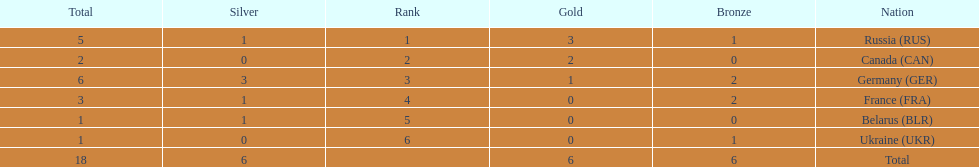Give me the full table as a dictionary. {'header': ['Total', 'Silver', 'Rank', 'Gold', 'Bronze', 'Nation'], 'rows': [['5', '1', '1', '3', '1', 'Russia\xa0(RUS)'], ['2', '0', '2', '2', '0', 'Canada\xa0(CAN)'], ['6', '3', '3', '1', '2', 'Germany\xa0(GER)'], ['3', '1', '4', '0', '2', 'France\xa0(FRA)'], ['1', '1', '5', '0', '0', 'Belarus\xa0(BLR)'], ['1', '0', '6', '0', '1', 'Ukraine\xa0(UKR)'], ['18', '6', '', '6', '6', 'Total']]} What was the total number of silver medals awarded to the french and the germans in the 1994 winter olympic biathlon? 4. 